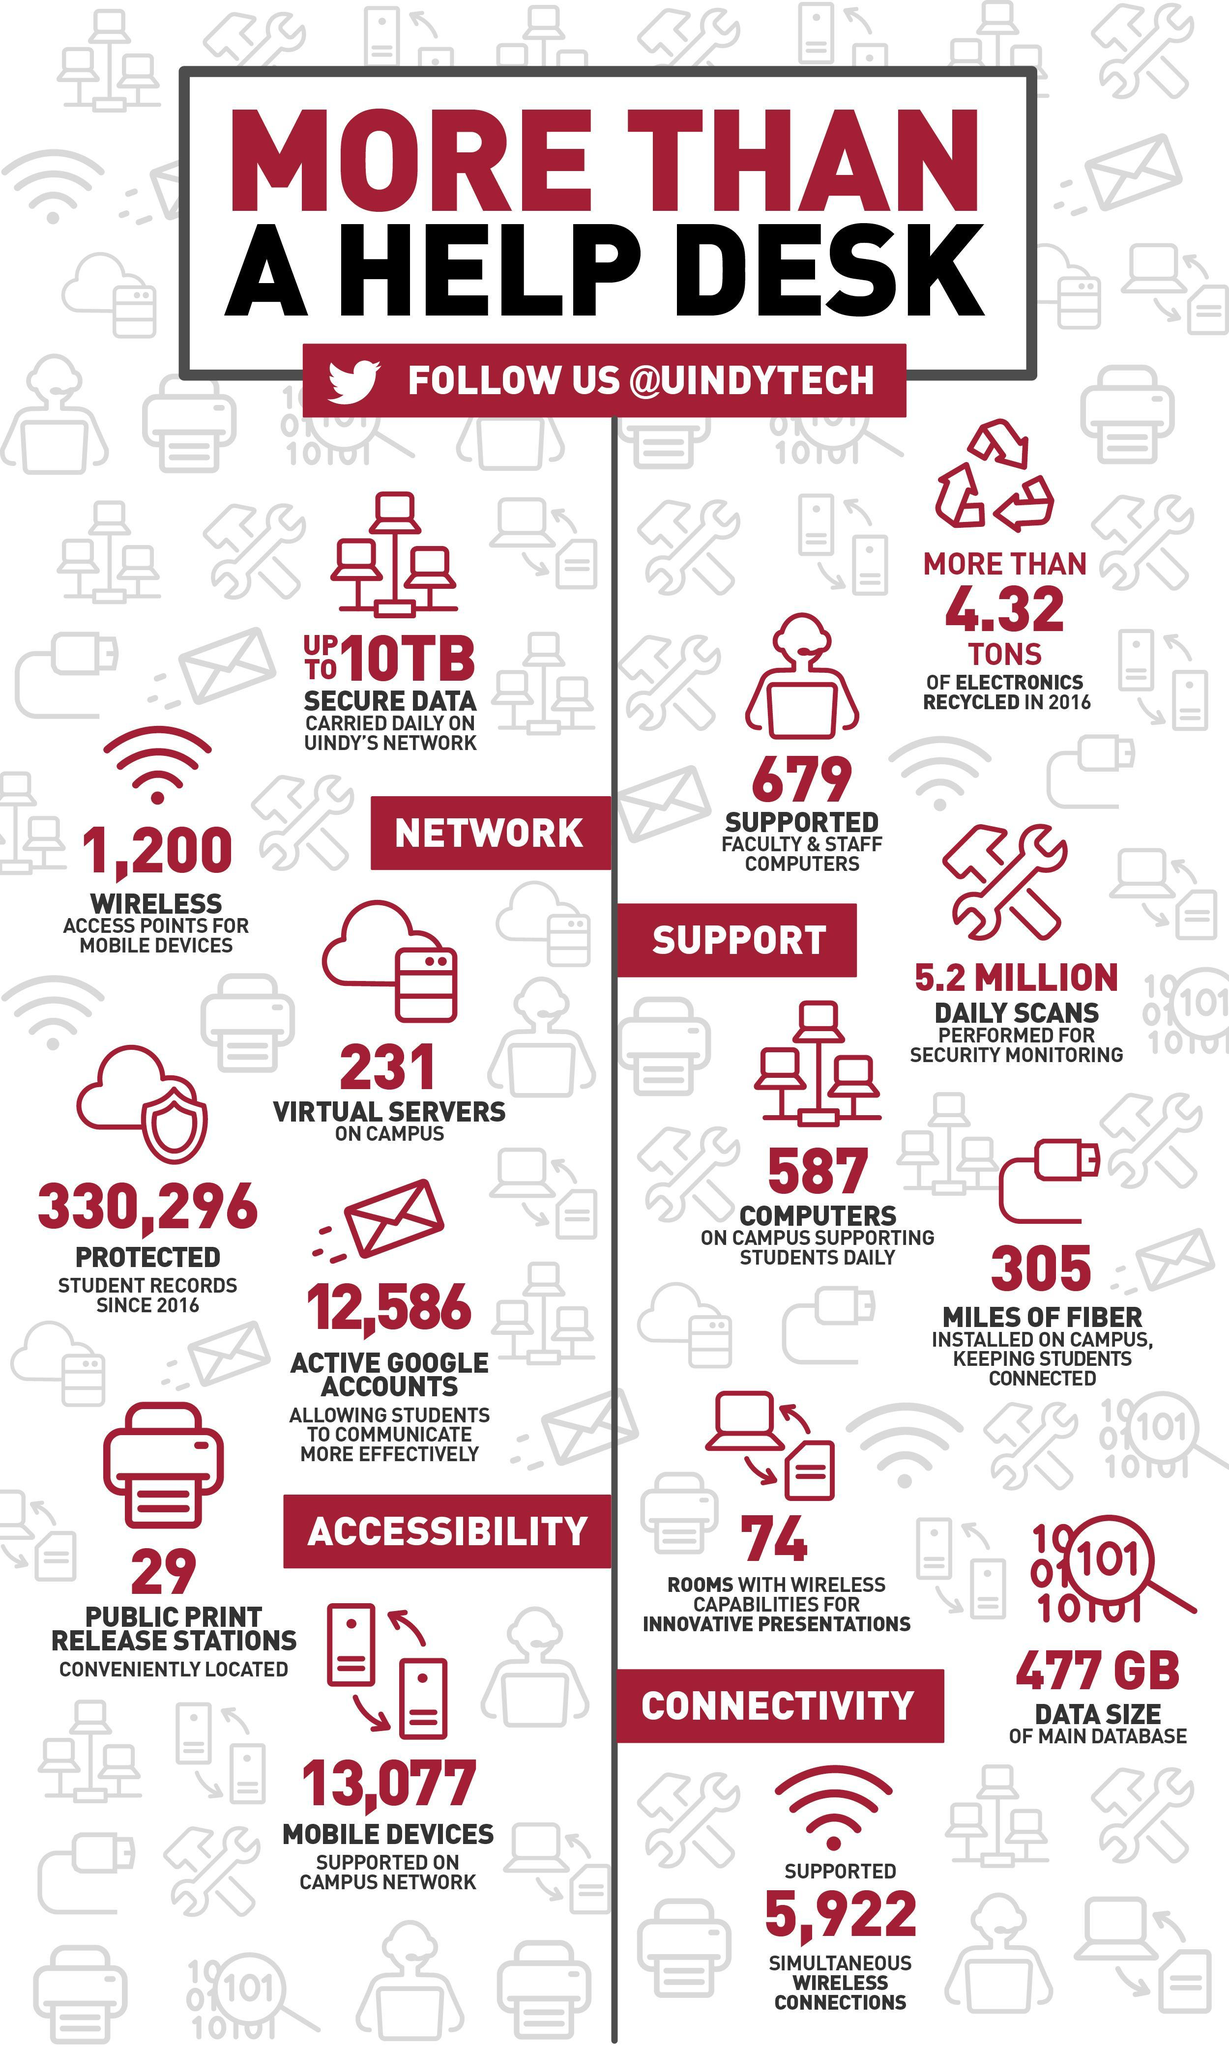how much data has been carried out daily on UINDY's network?
Answer the question with a short phrase. upto 10TB 